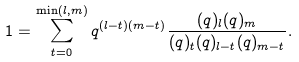<formula> <loc_0><loc_0><loc_500><loc_500>1 = \sum _ { t = 0 } ^ { \min ( l , m ) } q ^ { ( l - t ) ( m - t ) } \frac { ( q ) _ { l } ( q ) _ { m } } { ( q ) _ { t } ( q ) _ { l - t } ( q ) _ { m - t } } .</formula> 